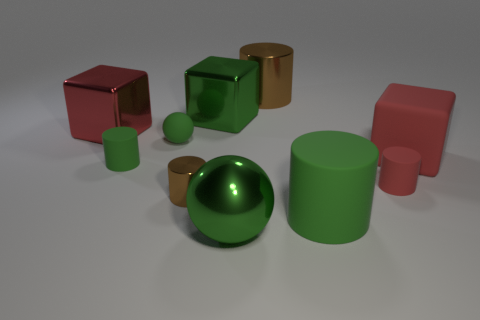What number of brown cylinders are in front of the brown metal cylinder in front of the metallic cylinder behind the small brown cylinder?
Ensure brevity in your answer.  0. The metallic thing that is the same color as the tiny metallic cylinder is what shape?
Your answer should be compact. Cylinder. Does the large rubber cube have the same color as the small thing on the right side of the tiny brown thing?
Your answer should be compact. Yes. Are there more large metal things on the left side of the tiny brown cylinder than small brown rubber things?
Your answer should be compact. Yes. How many things are either large red blocks that are to the right of the large sphere or rubber things that are behind the tiny metallic thing?
Provide a succinct answer. 4. There is a red object that is made of the same material as the red cylinder; what is its size?
Offer a very short reply. Large. There is a large shiny thing in front of the red metal thing; is its shape the same as the small red thing?
Make the answer very short. No. There is a metal object that is the same color as the metal sphere; what size is it?
Provide a short and direct response. Large. How many purple objects are small cylinders or tiny metallic objects?
Provide a succinct answer. 0. How many other things are there of the same shape as the tiny metallic thing?
Ensure brevity in your answer.  4. 